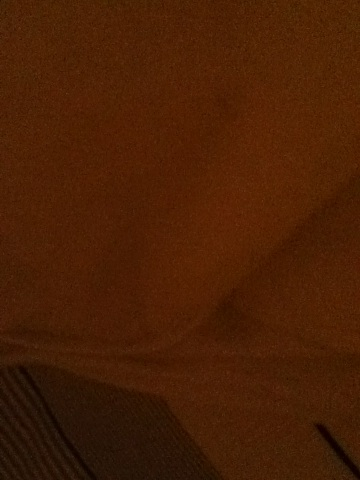How could we utilize this image for an art project? This image could be used as an inspiration for an art project focusing on texture and light. You could recreate the fabric pattern in a more detailed, larger piece, experimenting with different lighting angles to see how it affects the perception of texture. Another idea is to use the subtlety of the image to inspire abstract art that plays with shadows and muted colors. What themes could be explored using this image? Themes of warmth, comfort, and domesticity could be explored through this image. The interaction of light and shadow can also evoke a sense of mystery and intrigue. Additionally, ideas of simplicity and minimalism are inherent to the understated nature of the image. Exploring tactile senses through visual art could also be another theme given the fabric’s texture. What if the fabric had magical properties? What kind of story could that inspire? If the fabric had magical properties, it could inspire a fantastical story where it acts as a portal to another realm whenever it catches a shadow in a certain way. Characters could use it to visit enchanted lands, learn ancient secrets, or meet mystical creatures. The fabric could change color based on the emotions of those it touches, guiding them toward joy or comforting sorrow. Create a detailed plot involving this magical fabric. In a small, quiet village, an old weaver crafts a unique fabric with mysterious, ancient techniques passed down through generations. This fabric, when placed under certain light, reveals hidden doorways to alternate dimensions. A young orphan discovers the fabric in the attic of the orphanage and realizes its powers. Throughout the story, the child uses the fabric to escape the harsh reality of the orphanage, finding solace and adventure in magical realms. Along the way, they uncover hidden strengths within themselves and gather a motley crew of friends from different worlds. Together, they embark on a quest to protect the fabric’s secret from an evil sorcerer who seeks to exploit its power for dark purposes. Can you describe a short scenario where the fabric has magical properties? A weary traveler discovers the fabric, and when they wrap it around themselves, they are instantly transported to a peaceful, enchanted forest where time slows, offering rest and rejuvenation before continuing their journey. 